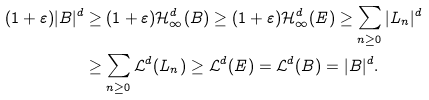Convert formula to latex. <formula><loc_0><loc_0><loc_500><loc_500>( 1 + \varepsilon ) | B | ^ { d } & \geq ( 1 + \varepsilon ) \mathcal { H } ^ { d } _ { \infty } ( B ) \geq ( 1 + \varepsilon ) \mathcal { H } ^ { d } _ { \infty } ( E ) \geq \sum _ { n \geq 0 } | L _ { n } | ^ { d } \\ & \geq \sum _ { n \geq 0 } \mathcal { L } ^ { d } ( L _ { n } ) \geq \mathcal { L } ^ { d } ( E ) = \mathcal { L } ^ { d } ( B ) = | B | ^ { d } .</formula> 